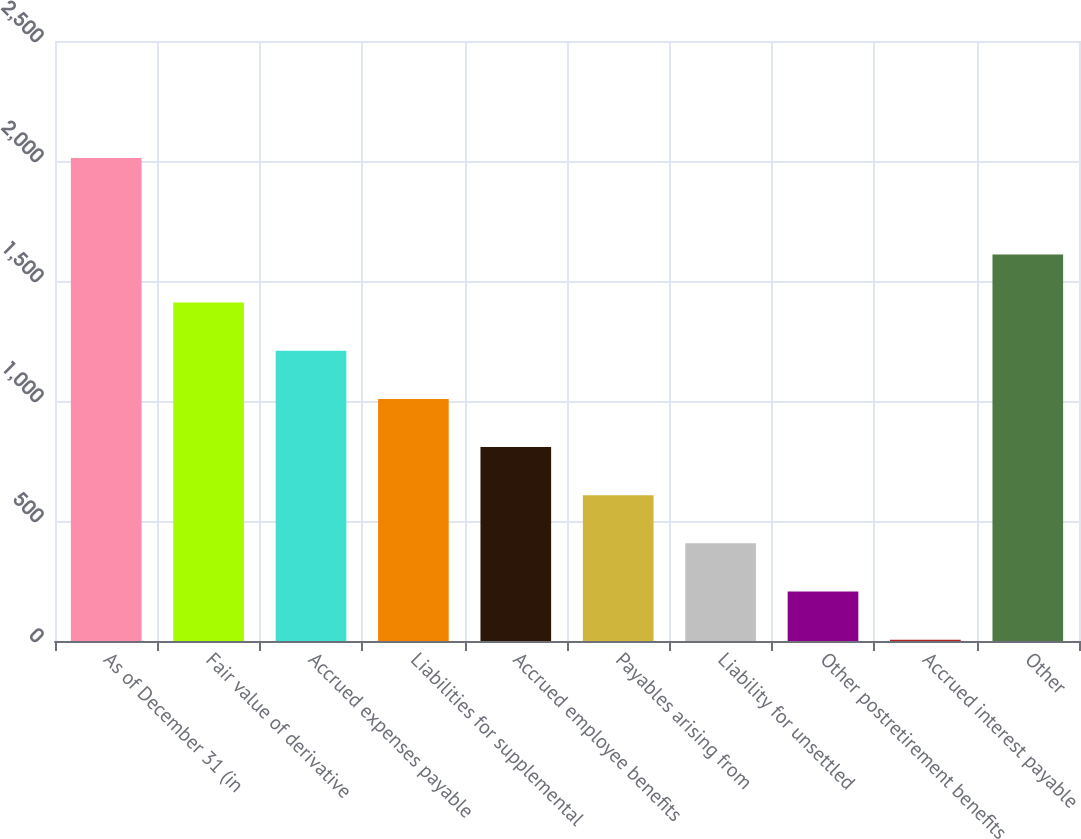<chart> <loc_0><loc_0><loc_500><loc_500><bar_chart><fcel>As of December 31 (in<fcel>Fair value of derivative<fcel>Accrued expenses payable<fcel>Liabilities for supplemental<fcel>Accrued employee benefits<fcel>Payables arising from<fcel>Liability for unsettled<fcel>Other postretirement benefits<fcel>Accrued interest payable<fcel>Other<nl><fcel>2012<fcel>1410.08<fcel>1209.44<fcel>1008.8<fcel>808.16<fcel>607.52<fcel>406.88<fcel>206.24<fcel>5.6<fcel>1610.72<nl></chart> 